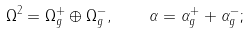<formula> <loc_0><loc_0><loc_500><loc_500>\Omega ^ { 2 } = \Omega _ { g } ^ { + } \oplus \Omega _ { g } ^ { - } , \quad \alpha = \alpha _ { g } ^ { + } + \alpha _ { g } ^ { - } ;</formula> 